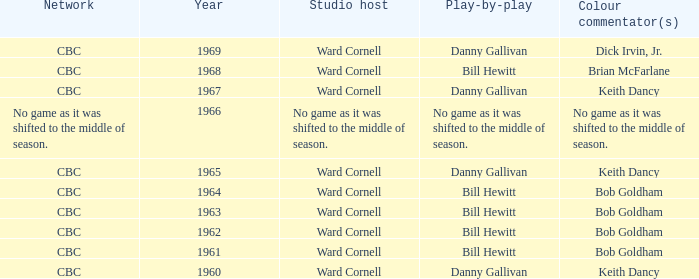Who did the play-by-play with studio host Ward Cornell and color commentator Bob Goldham? Bill Hewitt, Bill Hewitt, Bill Hewitt, Bill Hewitt. Would you be able to parse every entry in this table? {'header': ['Network', 'Year', 'Studio host', 'Play-by-play', 'Colour commentator(s)'], 'rows': [['CBC', '1969', 'Ward Cornell', 'Danny Gallivan', 'Dick Irvin, Jr.'], ['CBC', '1968', 'Ward Cornell', 'Bill Hewitt', 'Brian McFarlane'], ['CBC', '1967', 'Ward Cornell', 'Danny Gallivan', 'Keith Dancy'], ['No game as it was shifted to the middle of season.', '1966', 'No game as it was shifted to the middle of season.', 'No game as it was shifted to the middle of season.', 'No game as it was shifted to the middle of season.'], ['CBC', '1965', 'Ward Cornell', 'Danny Gallivan', 'Keith Dancy'], ['CBC', '1964', 'Ward Cornell', 'Bill Hewitt', 'Bob Goldham'], ['CBC', '1963', 'Ward Cornell', 'Bill Hewitt', 'Bob Goldham'], ['CBC', '1962', 'Ward Cornell', 'Bill Hewitt', 'Bob Goldham'], ['CBC', '1961', 'Ward Cornell', 'Bill Hewitt', 'Bob Goldham'], ['CBC', '1960', 'Ward Cornell', 'Danny Gallivan', 'Keith Dancy']]} 